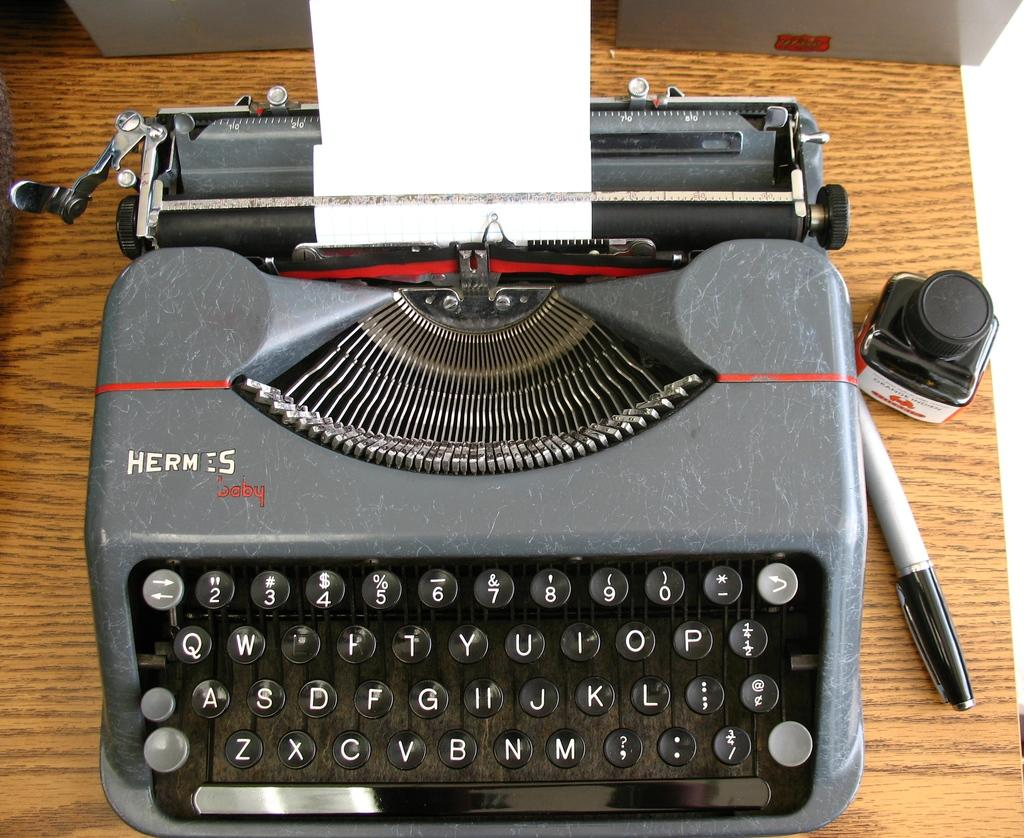<image>
Create a compact narrative representing the image presented. A old Hermes typewriter and a marker and bottle of ink sitting next to it. 